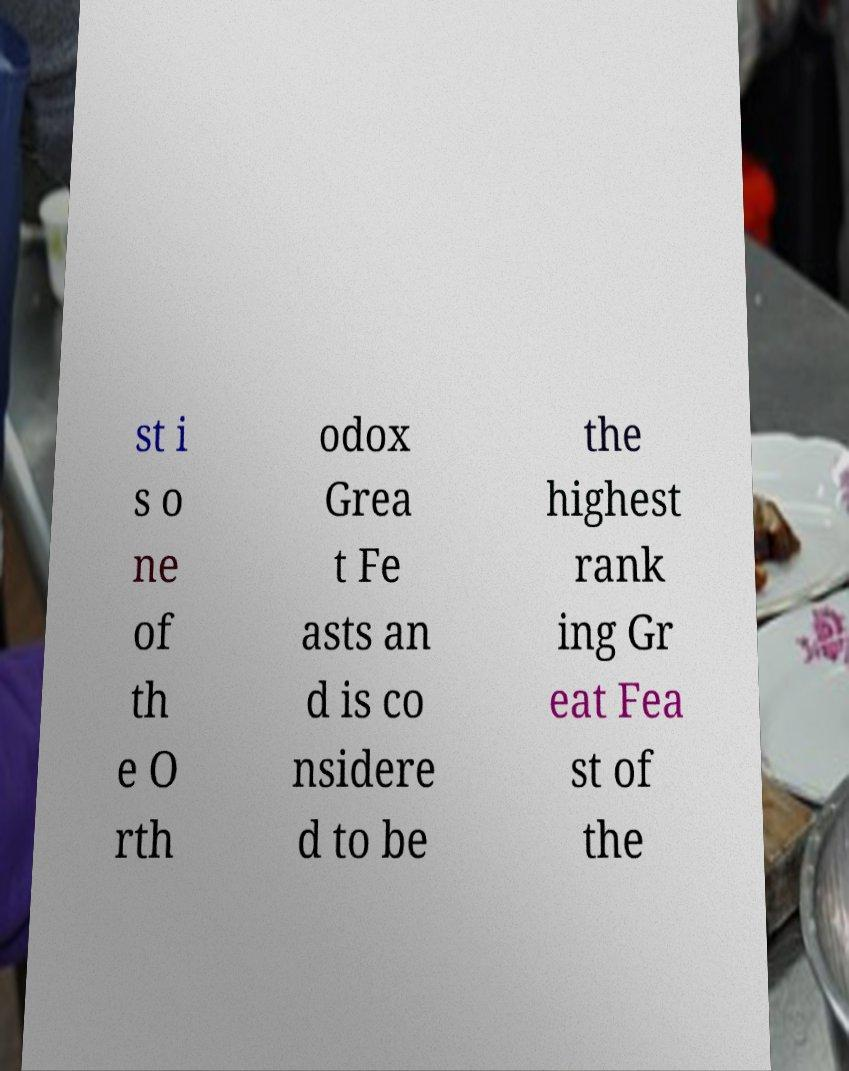Can you accurately transcribe the text from the provided image for me? st i s o ne of th e O rth odox Grea t Fe asts an d is co nsidere d to be the highest rank ing Gr eat Fea st of the 